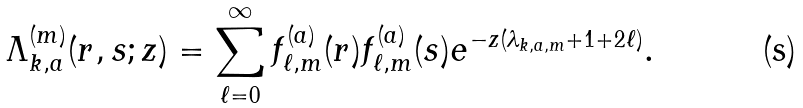<formula> <loc_0><loc_0><loc_500><loc_500>\Lambda _ { k , a } ^ { ( m ) } ( r , s ; z ) = \sum _ { \ell = 0 } ^ { \infty } f _ { \ell , m } ^ { ( a ) } ( r ) f _ { \ell , m } ^ { ( a ) } ( s ) e ^ { - z ( \lambda _ { k , a , m } + 1 + 2 \ell ) } .</formula> 